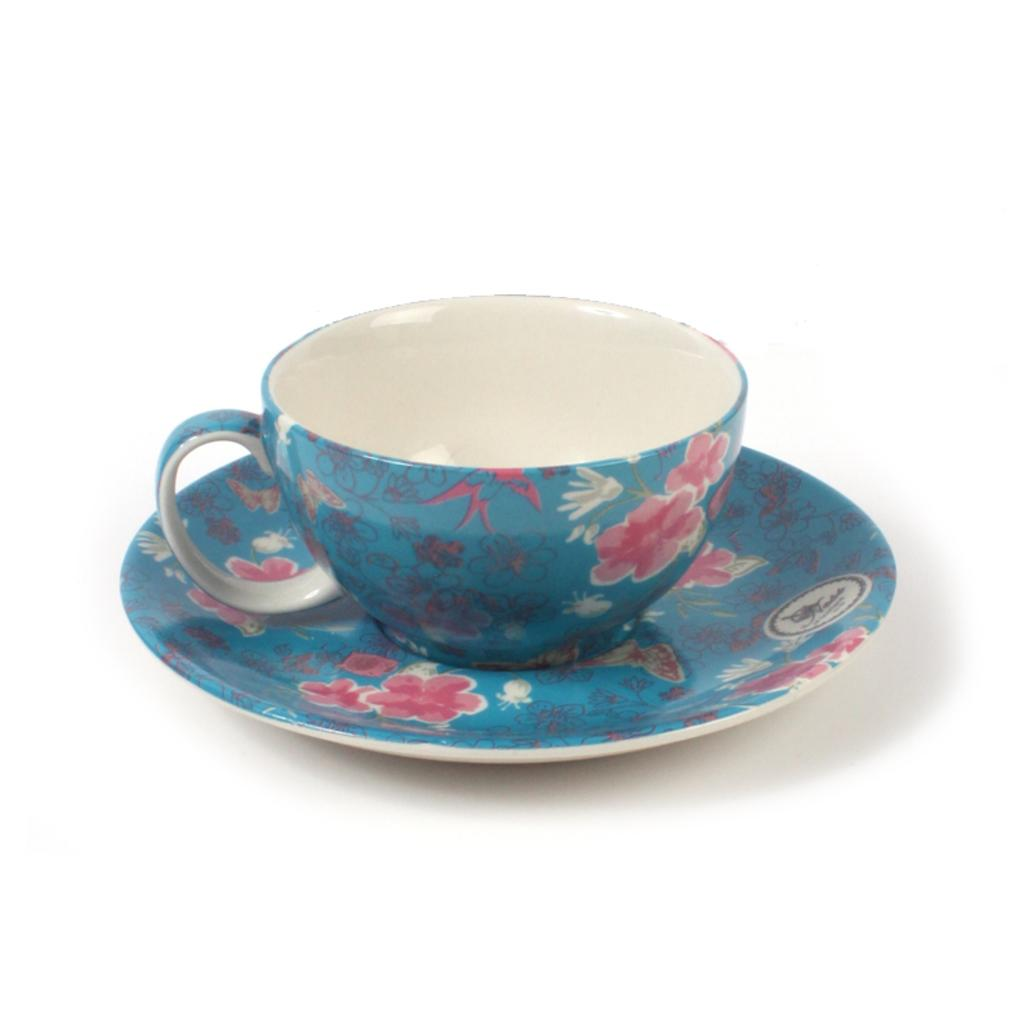What is present on the surface in the image? There is a cup in the image. Is the cup placed on any other object? Yes, the cup is on a saucer. What color is the background of the image? The background of the image is white. What type of powder is being used on the stove in the image? There is no stove or powder present in the image; it only features a cup on a saucer with a white background. 